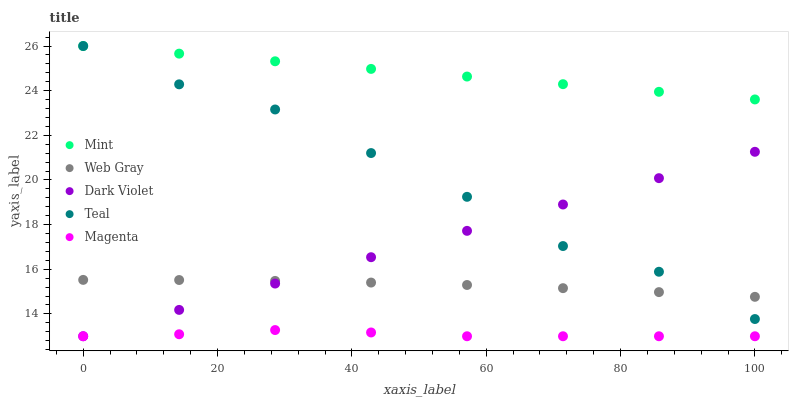Does Magenta have the minimum area under the curve?
Answer yes or no. Yes. Does Mint have the maximum area under the curve?
Answer yes or no. Yes. Does Web Gray have the minimum area under the curve?
Answer yes or no. No. Does Web Gray have the maximum area under the curve?
Answer yes or no. No. Is Dark Violet the smoothest?
Answer yes or no. Yes. Is Teal the roughest?
Answer yes or no. Yes. Is Web Gray the smoothest?
Answer yes or no. No. Is Web Gray the roughest?
Answer yes or no. No. Does Magenta have the lowest value?
Answer yes or no. Yes. Does Web Gray have the lowest value?
Answer yes or no. No. Does Teal have the highest value?
Answer yes or no. Yes. Does Web Gray have the highest value?
Answer yes or no. No. Is Web Gray less than Mint?
Answer yes or no. Yes. Is Mint greater than Web Gray?
Answer yes or no. Yes. Does Magenta intersect Dark Violet?
Answer yes or no. Yes. Is Magenta less than Dark Violet?
Answer yes or no. No. Is Magenta greater than Dark Violet?
Answer yes or no. No. Does Web Gray intersect Mint?
Answer yes or no. No. 